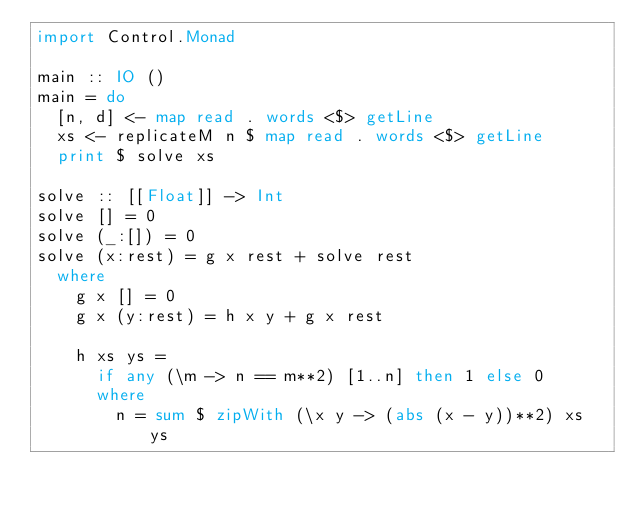<code> <loc_0><loc_0><loc_500><loc_500><_Haskell_>import Control.Monad

main :: IO ()
main = do
  [n, d] <- map read . words <$> getLine
  xs <- replicateM n $ map read . words <$> getLine
  print $ solve xs

solve :: [[Float]] -> Int
solve [] = 0
solve (_:[]) = 0
solve (x:rest) = g x rest + solve rest
  where
    g x [] = 0
    g x (y:rest) = h x y + g x rest

    h xs ys =
      if any (\m -> n == m**2) [1..n] then 1 else 0
      where
        n = sum $ zipWith (\x y -> (abs (x - y))**2) xs ys</code> 